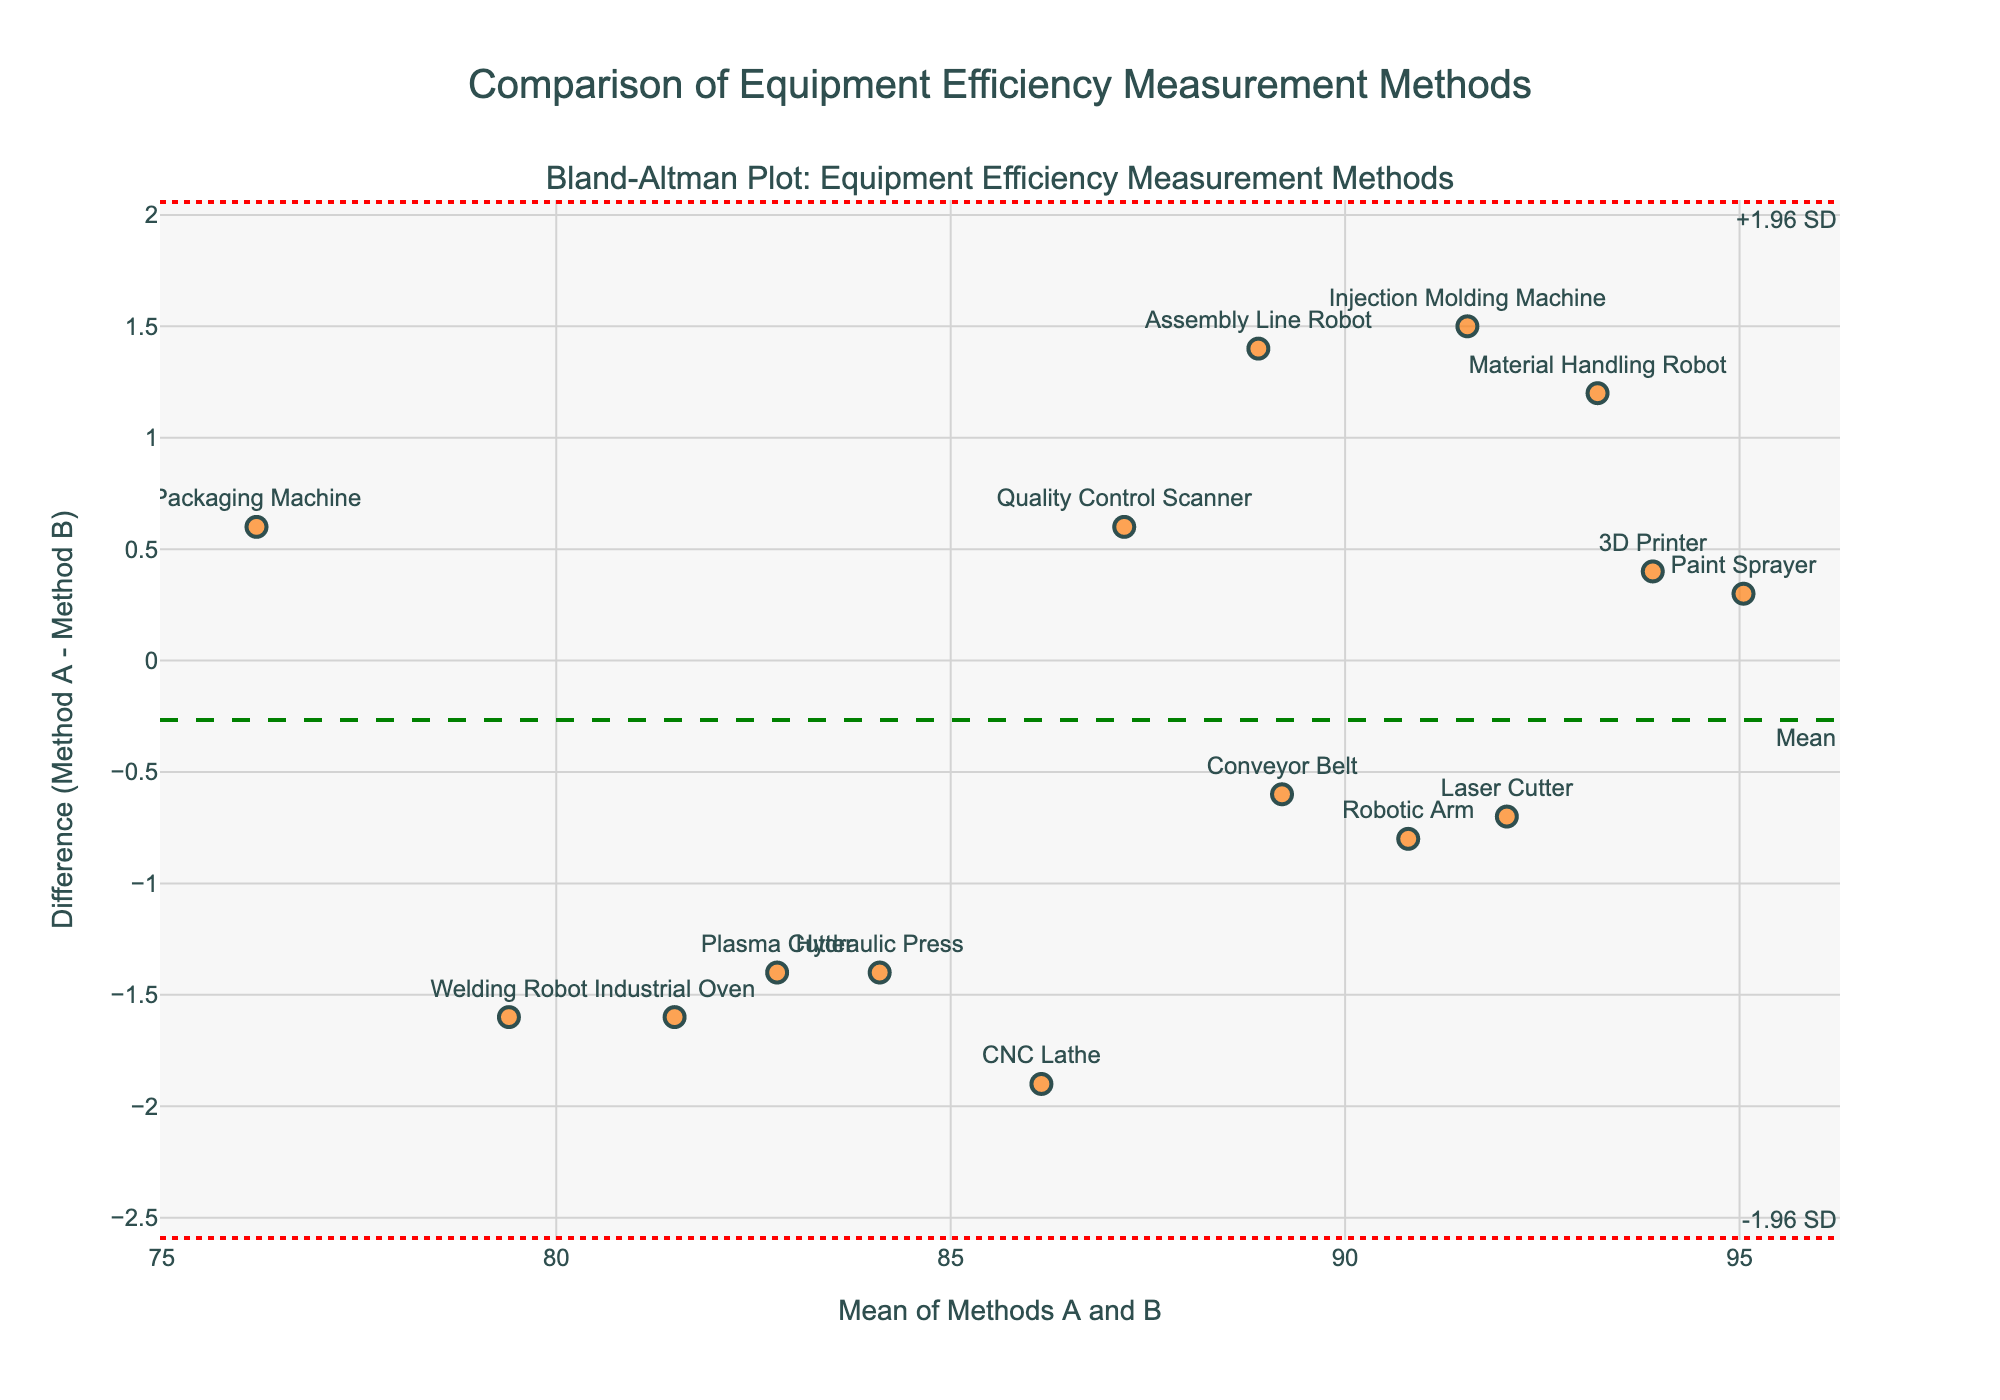How many pieces of equipment are shown in the plot? Each marker represents a piece of equipment on the plot. By counting them, we see there are 15 pieces of equipment.
Answer: 15 What does the y-axis represent? The y-axis shows the difference between Method A and Method B for each piece of equipment's efficiency measurement.
Answer: Difference (Method A - Method B) Which piece of equipment has the largest positive difference? We examine the y-values and identify the one with the highest positive value, then refer to the corresponding label. The equipment with the largest positive difference is the CNC Lathe.
Answer: CNC Lathe What's the mean of the differences between Method A and Method B? The mean difference is shown by the green dashed line on the plot. The label shows the exact value.
Answer: Mean difference Which piece of equipment is closest to the mean difference line? The equipment marked closest to the green dashed line for mean difference is the Conveyor Belt.
Answer: Conveyor Belt What is the range of the limits of agreement in this plot? The limits of agreement are depicted by the two red dotted lines. Reading the annotation text, they are -1.96 SD and +1.96 SD.
Answer: -1.96 SD to +1.96 SD How do the measurements of the Packaging Machine differ between the two methods? Find the Packaging Machine marker on the plot and read its y-value. Since the y-axis is the difference (Method A - Method B), check its value.
Answer: 0.6 (lower in Method B) Which equipment has a measurement difference closest to the lower limit of agreement? Check which piece of equipment's marker is nearest to the lower red dotted line, which represents -1.96 SD. The Welding Robot is closest.
Answer: Welding Robot Which method tends to give higher efficiency measurements, Method A or Method B? Observe where most differences fall (above or below the zero line). If negative, Method B is usually higher; if positive, Method A is higher. Most points are around zero.
Answer: Similar What best explains the significance of the red dotted lines on the plot? The red dotted lines represent the limits of agreement, which indicate the range within which 95% of the differences between the methods should fall.
Answer: Limits of agreement 